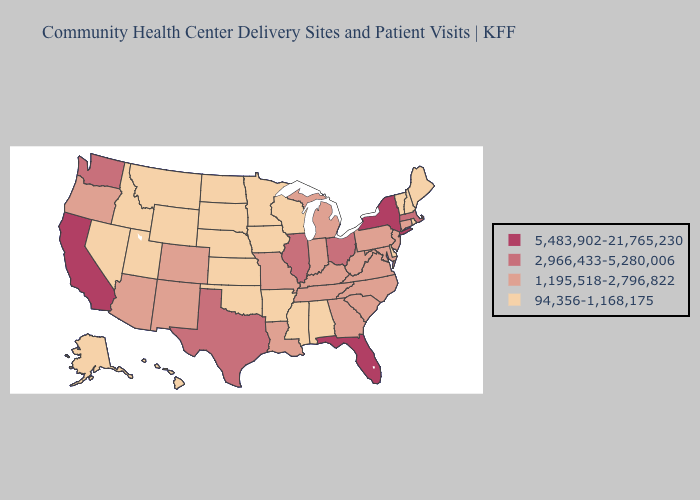How many symbols are there in the legend?
Be succinct. 4. Name the states that have a value in the range 94,356-1,168,175?
Keep it brief. Alabama, Alaska, Arkansas, Delaware, Hawaii, Idaho, Iowa, Kansas, Maine, Minnesota, Mississippi, Montana, Nebraska, Nevada, New Hampshire, North Dakota, Oklahoma, Rhode Island, South Dakota, Utah, Vermont, Wisconsin, Wyoming. What is the highest value in the South ?
Be succinct. 5,483,902-21,765,230. Does Rhode Island have the lowest value in the USA?
Keep it brief. Yes. How many symbols are there in the legend?
Be succinct. 4. What is the value of New Jersey?
Write a very short answer. 1,195,518-2,796,822. Which states hav the highest value in the South?
Be succinct. Florida. Among the states that border California , does Nevada have the highest value?
Be succinct. No. What is the value of California?
Answer briefly. 5,483,902-21,765,230. Does California have the highest value in the West?
Quick response, please. Yes. Which states have the lowest value in the West?
Quick response, please. Alaska, Hawaii, Idaho, Montana, Nevada, Utah, Wyoming. Does North Dakota have the highest value in the USA?
Short answer required. No. Which states have the highest value in the USA?
Be succinct. California, Florida, New York. Among the states that border Oregon , which have the highest value?
Keep it brief. California. What is the highest value in states that border Delaware?
Short answer required. 1,195,518-2,796,822. 